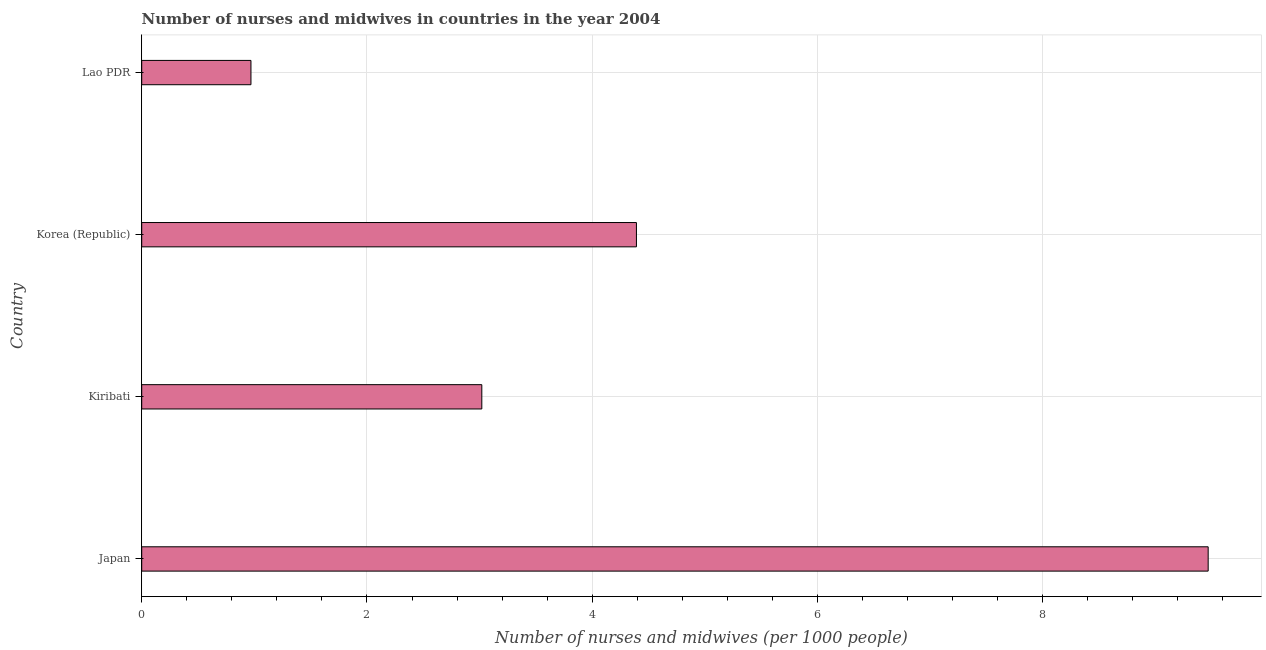Does the graph contain grids?
Ensure brevity in your answer.  Yes. What is the title of the graph?
Offer a very short reply. Number of nurses and midwives in countries in the year 2004. What is the label or title of the X-axis?
Offer a terse response. Number of nurses and midwives (per 1000 people). What is the label or title of the Y-axis?
Make the answer very short. Country. What is the number of nurses and midwives in Japan?
Keep it short and to the point. 9.47. Across all countries, what is the maximum number of nurses and midwives?
Your answer should be compact. 9.47. Across all countries, what is the minimum number of nurses and midwives?
Offer a very short reply. 0.97. In which country was the number of nurses and midwives maximum?
Your response must be concise. Japan. In which country was the number of nurses and midwives minimum?
Keep it short and to the point. Lao PDR. What is the sum of the number of nurses and midwives?
Keep it short and to the point. 17.85. What is the difference between the number of nurses and midwives in Japan and Lao PDR?
Your response must be concise. 8.5. What is the average number of nurses and midwives per country?
Give a very brief answer. 4.46. What is the median number of nurses and midwives?
Ensure brevity in your answer.  3.71. What is the ratio of the number of nurses and midwives in Korea (Republic) to that in Lao PDR?
Provide a short and direct response. 4.53. What is the difference between the highest and the second highest number of nurses and midwives?
Your answer should be compact. 5.08. Is the sum of the number of nurses and midwives in Kiribati and Lao PDR greater than the maximum number of nurses and midwives across all countries?
Ensure brevity in your answer.  No. How many bars are there?
Ensure brevity in your answer.  4. Are the values on the major ticks of X-axis written in scientific E-notation?
Keep it short and to the point. No. What is the Number of nurses and midwives (per 1000 people) in Japan?
Keep it short and to the point. 9.47. What is the Number of nurses and midwives (per 1000 people) in Kiribati?
Your answer should be very brief. 3.02. What is the Number of nurses and midwives (per 1000 people) of Korea (Republic)?
Your answer should be compact. 4.39. What is the Number of nurses and midwives (per 1000 people) in Lao PDR?
Your answer should be compact. 0.97. What is the difference between the Number of nurses and midwives (per 1000 people) in Japan and Kiribati?
Offer a terse response. 6.45. What is the difference between the Number of nurses and midwives (per 1000 people) in Japan and Korea (Republic)?
Your response must be concise. 5.08. What is the difference between the Number of nurses and midwives (per 1000 people) in Japan and Lao PDR?
Provide a short and direct response. 8.5. What is the difference between the Number of nurses and midwives (per 1000 people) in Kiribati and Korea (Republic)?
Provide a short and direct response. -1.37. What is the difference between the Number of nurses and midwives (per 1000 people) in Kiribati and Lao PDR?
Give a very brief answer. 2.05. What is the difference between the Number of nurses and midwives (per 1000 people) in Korea (Republic) and Lao PDR?
Your answer should be compact. 3.42. What is the ratio of the Number of nurses and midwives (per 1000 people) in Japan to that in Kiribati?
Provide a short and direct response. 3.14. What is the ratio of the Number of nurses and midwives (per 1000 people) in Japan to that in Korea (Republic)?
Make the answer very short. 2.16. What is the ratio of the Number of nurses and midwives (per 1000 people) in Japan to that in Lao PDR?
Provide a succinct answer. 9.76. What is the ratio of the Number of nurses and midwives (per 1000 people) in Kiribati to that in Korea (Republic)?
Ensure brevity in your answer.  0.69. What is the ratio of the Number of nurses and midwives (per 1000 people) in Kiribati to that in Lao PDR?
Provide a short and direct response. 3.11. What is the ratio of the Number of nurses and midwives (per 1000 people) in Korea (Republic) to that in Lao PDR?
Your answer should be compact. 4.53. 